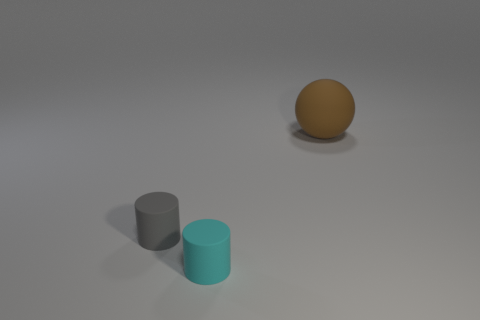Imagine if these objects were part of a larger scene, what could be their function? If these objects were part of a larger scene, they could serve various functions. The gray cylinder might act as a base or stand for another object, the cyan cylinder could be a decorative piece or part of a modular assembly, and the brown sphere may serve as a prop or model in a physics demonstration or as a simple decorative element in a minimalist setting. 